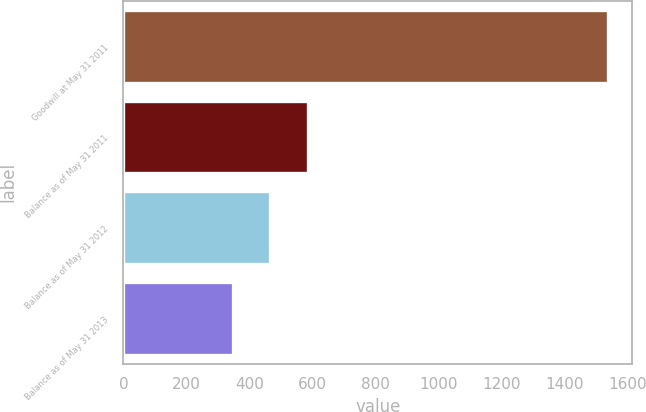Convert chart to OTSL. <chart><loc_0><loc_0><loc_500><loc_500><bar_chart><fcel>Goodwill at May 31 2011<fcel>Balance as of May 31 2011<fcel>Balance as of May 31 2012<fcel>Balance as of May 31 2013<nl><fcel>1539<fcel>586.2<fcel>467.1<fcel>348<nl></chart> 